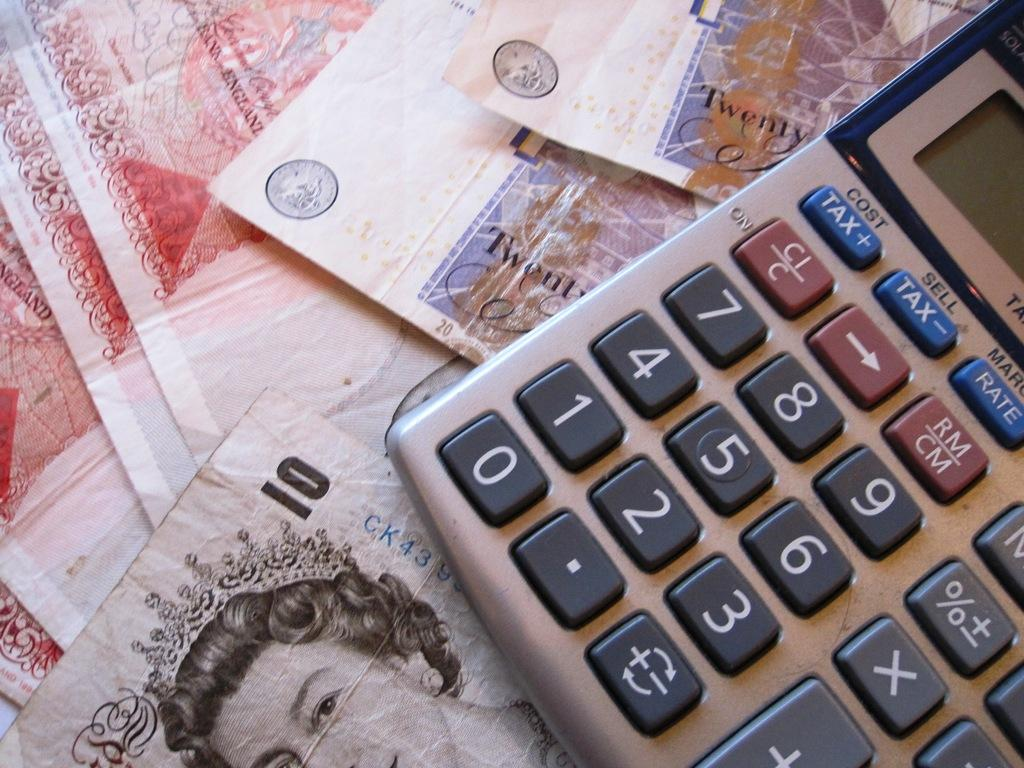Provide a one-sentence caption for the provided image. A calculator sitting on top of several twenty and ten pound notes. 